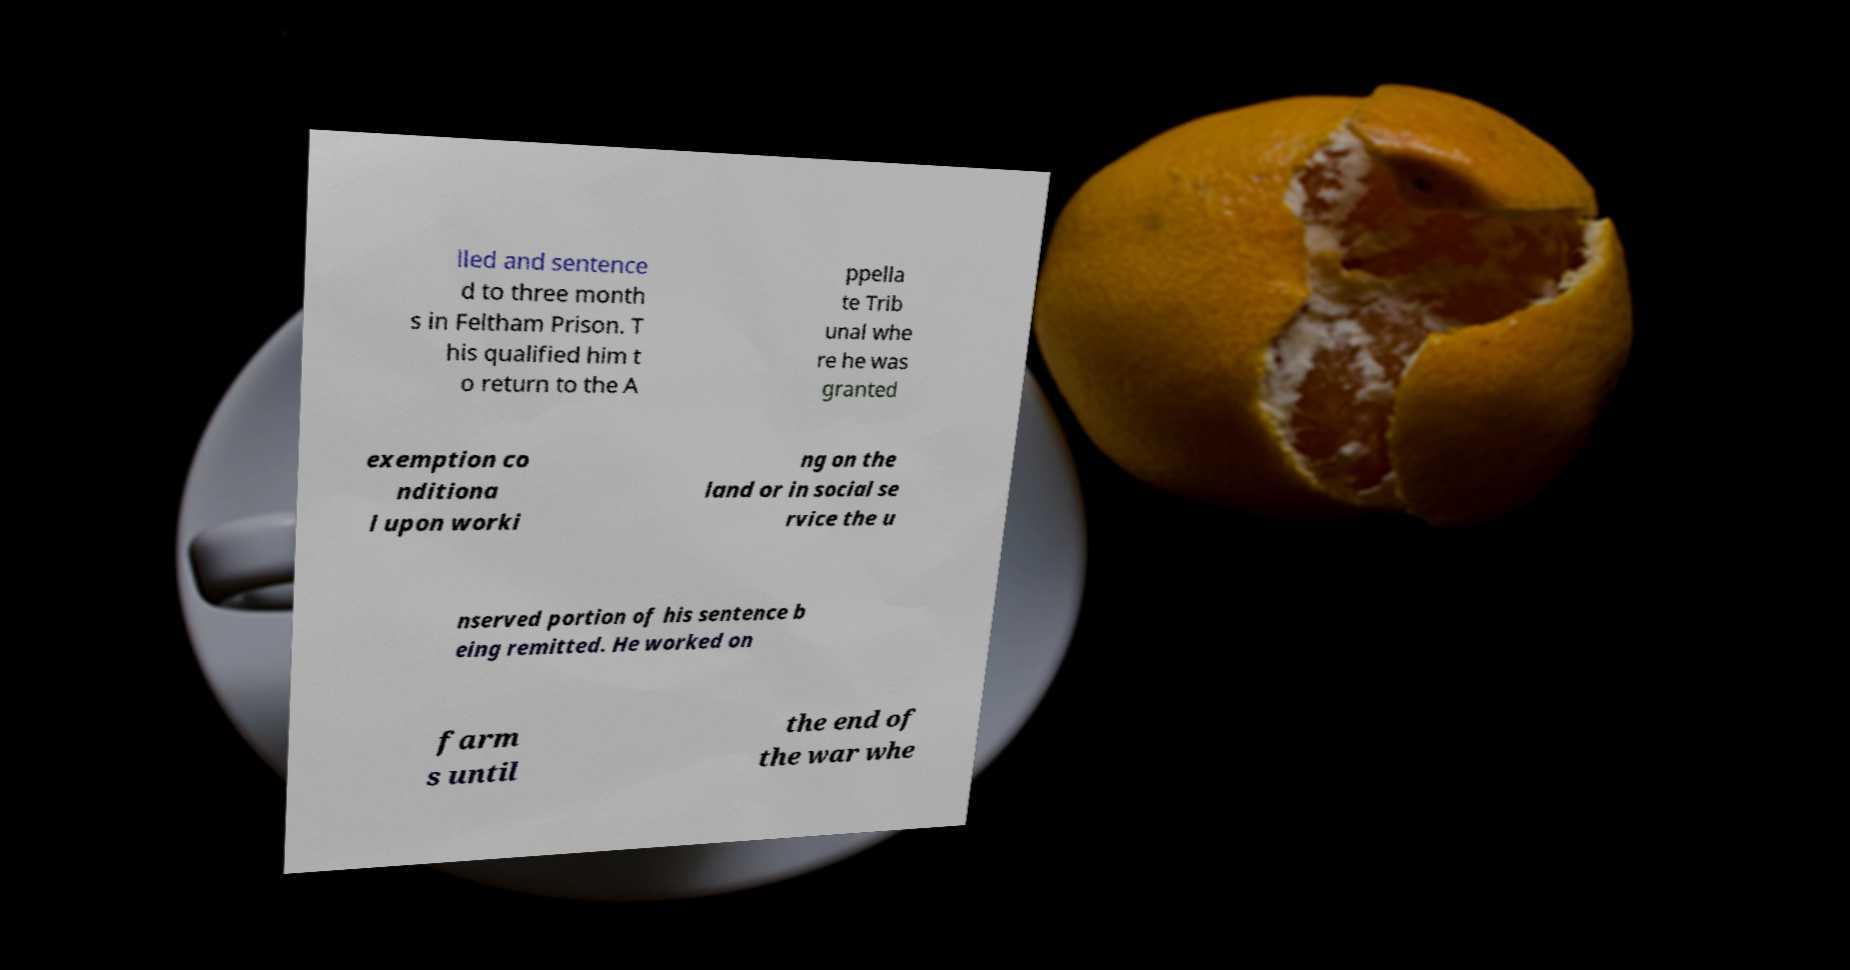Please identify and transcribe the text found in this image. lled and sentence d to three month s in Feltham Prison. T his qualified him t o return to the A ppella te Trib unal whe re he was granted exemption co nditiona l upon worki ng on the land or in social se rvice the u nserved portion of his sentence b eing remitted. He worked on farm s until the end of the war whe 